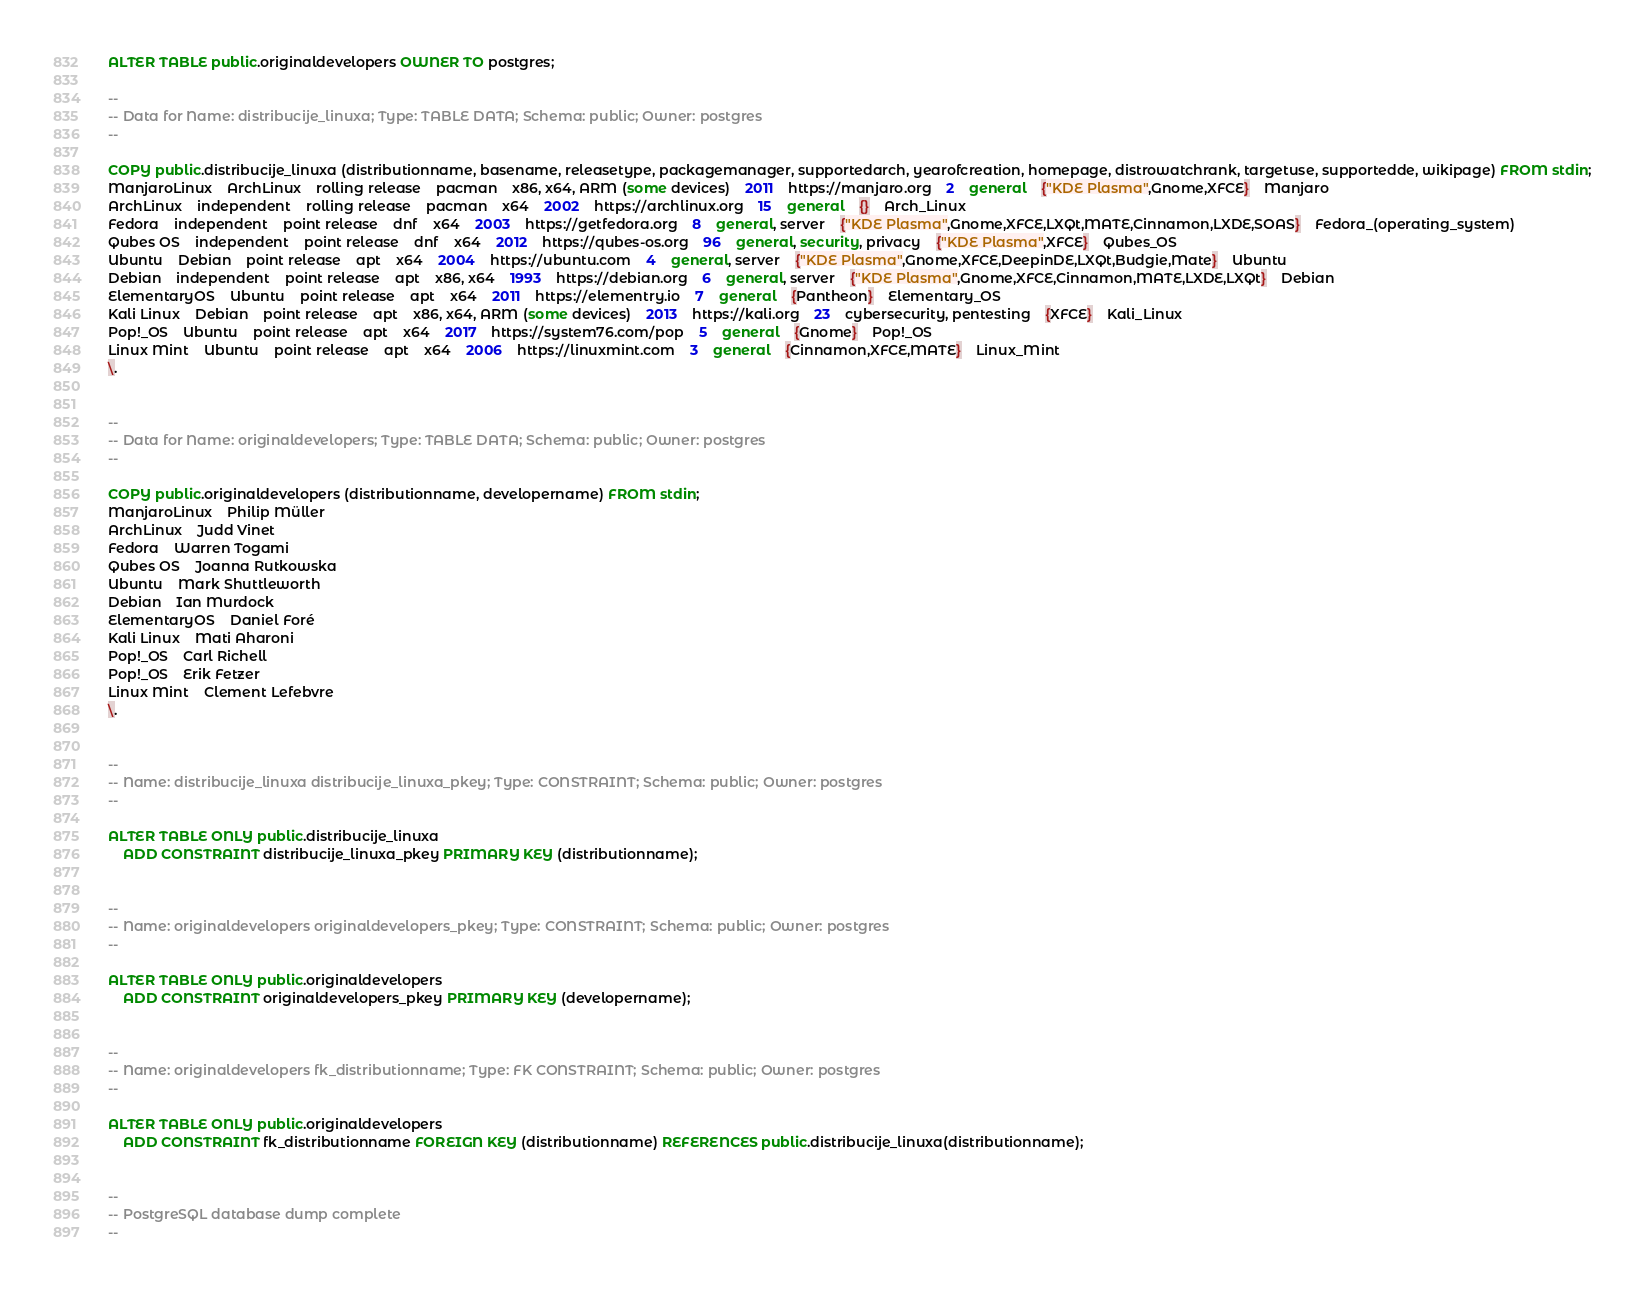<code> <loc_0><loc_0><loc_500><loc_500><_SQL_>
ALTER TABLE public.originaldevelopers OWNER TO postgres;

--
-- Data for Name: distribucije_linuxa; Type: TABLE DATA; Schema: public; Owner: postgres
--

COPY public.distribucije_linuxa (distributionname, basename, releasetype, packagemanager, supportedarch, yearofcreation, homepage, distrowatchrank, targetuse, supportedde, wikipage) FROM stdin;
ManjaroLinux	ArchLinux	rolling release	pacman	x86, x64, ARM (some devices)	2011	https://manjaro.org	2	general	{"KDE Plasma",Gnome,XFCE}	Manjaro
ArchLinux	independent	rolling release	pacman	x64	2002	https://archlinux.org	15	general	{}	Arch_Linux
Fedora	independent	point release	dnf	x64	2003	https://getfedora.org	8	general, server	{"KDE Plasma",Gnome,XFCE,LXQt,MATE,Cinnamon,LXDE,SOAS}	Fedora_(operating_system)
Qubes OS	independent	point release	dnf	x64	2012	https://qubes-os.org	96	general, security, privacy	{"KDE Plasma",XFCE}	Qubes_OS
Ubuntu	Debian	point release	apt	x64	2004	https://ubuntu.com	4	general, server	{"KDE Plasma",Gnome,XFCE,DeepinDE,LXQt,Budgie,Mate}	Ubuntu
Debian	independent	point release	apt	x86, x64	1993	https://debian.org	6	general, server	{"KDE Plasma",Gnome,XFCE,Cinnamon,MATE,LXDE,LXQt}	Debian
ElementaryOS	Ubuntu	point release	apt	x64	2011	https://elementry.io	7	general	{Pantheon}	Elementary_OS
Kali Linux	Debian	point release	apt	x86, x64, ARM (some devices)	2013	https://kali.org	23	cybersecurity, pentesting	{XFCE}	Kali_Linux
Pop!_OS	Ubuntu	point release	apt	x64	2017	https://system76.com/pop	5	general	{Gnome}	Pop!_OS
Linux Mint	Ubuntu	point release	apt	x64	2006	https://linuxmint.com	3	general	{Cinnamon,XFCE,MATE}	Linux_Mint
\.


--
-- Data for Name: originaldevelopers; Type: TABLE DATA; Schema: public; Owner: postgres
--

COPY public.originaldevelopers (distributionname, developername) FROM stdin;
ManjaroLinux	Philip Müller
ArchLinux	Judd Vinet
Fedora	Warren Togami
Qubes OS	Joanna Rutkowska
Ubuntu	Mark Shuttleworth
Debian	Ian Murdock
ElementaryOS	Daniel Foré
Kali Linux	Mati Aharoni
Pop!_OS	Carl Richell
Pop!_OS	Erik Fetzer
Linux Mint	Clement Lefebvre
\.


--
-- Name: distribucije_linuxa distribucije_linuxa_pkey; Type: CONSTRAINT; Schema: public; Owner: postgres
--

ALTER TABLE ONLY public.distribucije_linuxa
    ADD CONSTRAINT distribucije_linuxa_pkey PRIMARY KEY (distributionname);


--
-- Name: originaldevelopers originaldevelopers_pkey; Type: CONSTRAINT; Schema: public; Owner: postgres
--

ALTER TABLE ONLY public.originaldevelopers
    ADD CONSTRAINT originaldevelopers_pkey PRIMARY KEY (developername);


--
-- Name: originaldevelopers fk_distributionname; Type: FK CONSTRAINT; Schema: public; Owner: postgres
--

ALTER TABLE ONLY public.originaldevelopers
    ADD CONSTRAINT fk_distributionname FOREIGN KEY (distributionname) REFERENCES public.distribucije_linuxa(distributionname);


--
-- PostgreSQL database dump complete
--

</code> 